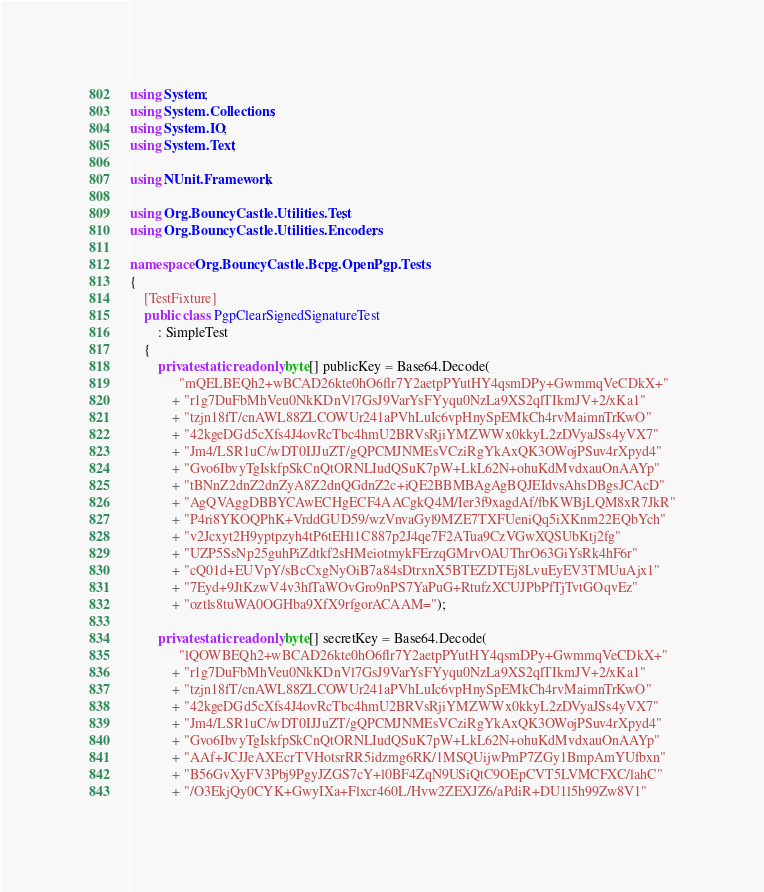<code> <loc_0><loc_0><loc_500><loc_500><_C#_>using System;
using System.Collections;
using System.IO;
using System.Text;

using NUnit.Framework;

using Org.BouncyCastle.Utilities.Test;
using Org.BouncyCastle.Utilities.Encoders;

namespace Org.BouncyCastle.Bcpg.OpenPgp.Tests
{
	[TestFixture]
	public class PgpClearSignedSignatureTest
		: SimpleTest
	{
		private static readonly byte[] publicKey = Base64.Decode(
			  "mQELBEQh2+wBCAD26kte0hO6flr7Y2aetpPYutHY4qsmDPy+GwmmqVeCDkX+"
			+ "r1g7DuFbMhVeu0NkKDnVl7GsJ9VarYsFYyqu0NzLa9XS2qlTIkmJV+2/xKa1"
			+ "tzjn18fT/cnAWL88ZLCOWUr241aPVhLuIc6vpHnySpEMkCh4rvMaimnTrKwO"
			+ "42kgeDGd5cXfs4J4ovRcTbc4hmU2BRVsRjiYMZWWx0kkyL2zDVyaJSs4yVX7"
			+ "Jm4/LSR1uC/wDT0IJJuZT/gQPCMJNMEsVCziRgYkAxQK3OWojPSuv4rXpyd4"
			+ "Gvo6IbvyTgIskfpSkCnQtORNLIudQSuK7pW+LkL62N+ohuKdMvdxauOnAAYp"
			+ "tBNnZ2dnZ2dnZyA8Z2dnQGdnZ2c+iQE2BBMBAgAgBQJEIdvsAhsDBgsJCAcD"
			+ "AgQVAggDBBYCAwECHgECF4AACgkQ4M/Ier3f9xagdAf/fbKWBjLQM8xR7JkR"
			+ "P4ri8YKOQPhK+VrddGUD59/wzVnvaGyl9MZE7TXFUeniQq5iXKnm22EQbYch"
			+ "v2Jcxyt2H9yptpzyh4tP6tEHl1C887p2J4qe7F2ATua9CzVGwXQSUbKtj2fg"
			+ "UZP5SsNp25guhPiZdtkf2sHMeiotmykFErzqGMrvOAUThrO63GiYsRk4hF6r"
			+ "cQ01d+EUVpY/sBcCxgNyOiB7a84sDtrxnX5BTEZDTEj8LvuEyEV3TMUuAjx1"
			+ "7Eyd+9JtKzwV4v3hlTaWOvGro9nPS7YaPuG+RtufzXCUJPbPfTjTvtGOqvEz"
			+ "oztls8tuWA0OGHba9XfX9rfgorACAAM=");

		private static readonly byte[] secretKey = Base64.Decode(
			  "lQOWBEQh2+wBCAD26kte0hO6flr7Y2aetpPYutHY4qsmDPy+GwmmqVeCDkX+"
			+ "r1g7DuFbMhVeu0NkKDnVl7GsJ9VarYsFYyqu0NzLa9XS2qlTIkmJV+2/xKa1"
			+ "tzjn18fT/cnAWL88ZLCOWUr241aPVhLuIc6vpHnySpEMkCh4rvMaimnTrKwO"
			+ "42kgeDGd5cXfs4J4ovRcTbc4hmU2BRVsRjiYMZWWx0kkyL2zDVyaJSs4yVX7"
			+ "Jm4/LSR1uC/wDT0IJJuZT/gQPCMJNMEsVCziRgYkAxQK3OWojPSuv4rXpyd4"
			+ "Gvo6IbvyTgIskfpSkCnQtORNLIudQSuK7pW+LkL62N+ohuKdMvdxauOnAAYp"
			+ "AAf+JCJJeAXEcrTVHotsrRR5idzmg6RK/1MSQUijwPmP7ZGy1BmpAmYUfbxn"
			+ "B56GvXyFV3Pbj9PgyJZGS7cY+l0BF4ZqN9USiQtC9OEpCVT5LVMCFXC/lahC"
			+ "/O3EkjQy0CYK+GwyIXa+Flxcr460L/Hvw2ZEXJZ6/aPdiR+DU1l5h99Zw8V1"</code> 